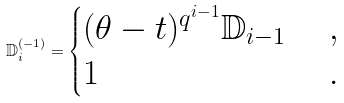<formula> <loc_0><loc_0><loc_500><loc_500>\mathbb { D } _ { i } ^ { ( - 1 ) } = \begin{cases} ( \theta - t ) ^ { q ^ { i - 1 } } \mathbb { D } _ { i - 1 } \ & , \\ 1 \ & . \end{cases}</formula> 